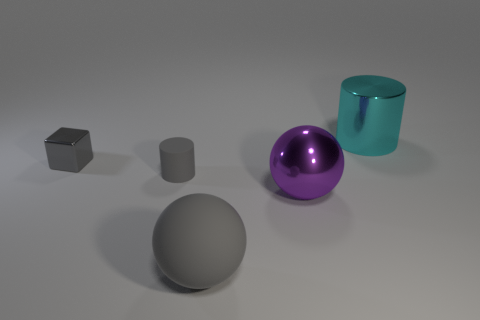Is there anything else that is the same shape as the gray metallic object?
Your answer should be very brief. No. Do the big sphere that is to the left of the large purple metallic ball and the small gray cylinder have the same material?
Your answer should be compact. Yes. What number of other things are there of the same size as the metallic cylinder?
Give a very brief answer. 2. How many tiny things are green cubes or metal cubes?
Your answer should be very brief. 1. Is the color of the big matte thing the same as the small cylinder?
Your response must be concise. Yes. Are there more metal things that are on the right side of the big gray thing than gray objects that are behind the gray cylinder?
Your answer should be very brief. Yes. There is a cylinder on the left side of the large gray rubber thing; does it have the same color as the metal block?
Provide a succinct answer. Yes. Is there anything else that has the same color as the shiny ball?
Make the answer very short. No. Is the number of metal things on the left side of the large metallic cylinder greater than the number of purple metallic cubes?
Ensure brevity in your answer.  Yes. Is the cyan metal cylinder the same size as the gray cube?
Offer a very short reply. No. 